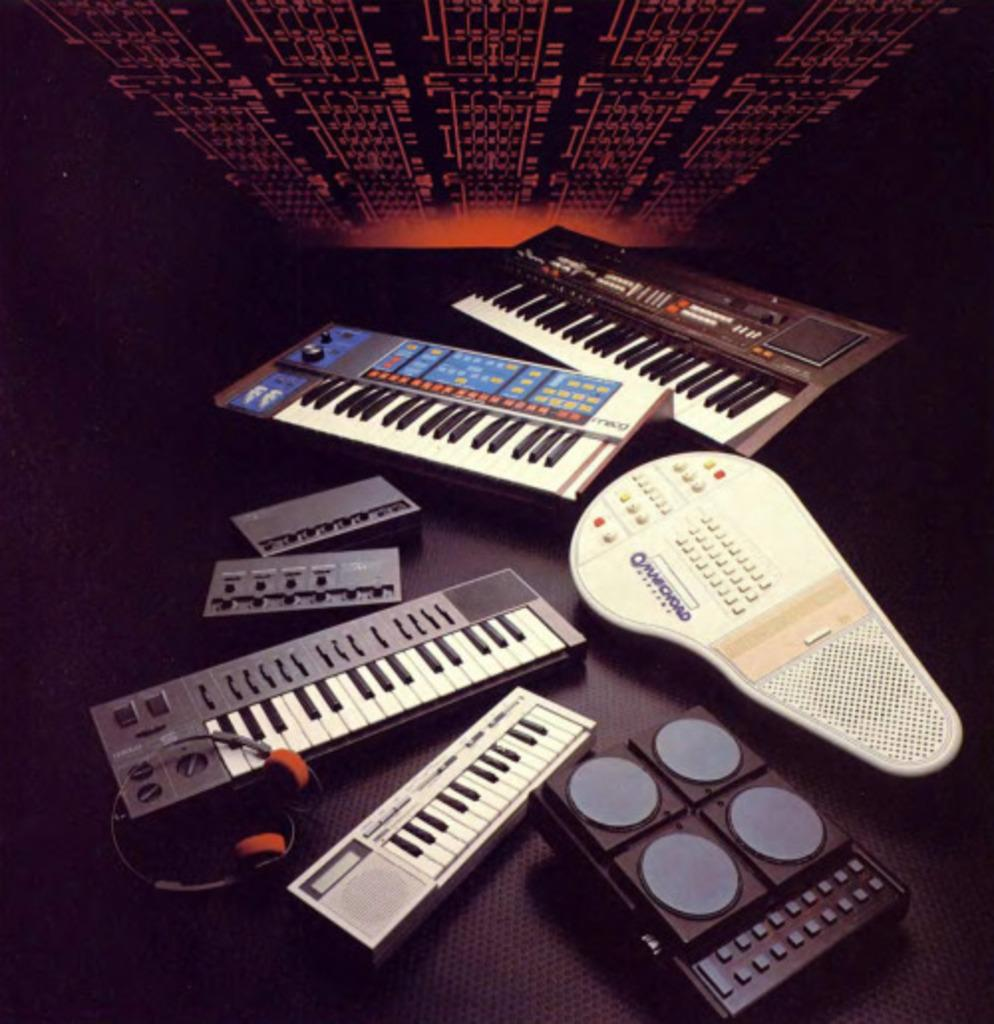What type of musical instrument is visible in the image? There are musical keyboards in the image. What device is present for audio communication? There is a headset in the image. What is the small speaker-like object in the image? There is a mini sound box in the image. How many umbrellas are being used by the musicians in the image? There are no umbrellas present in the image. What type of porter is assisting the musicians in the image? There are no porters present in the image. 